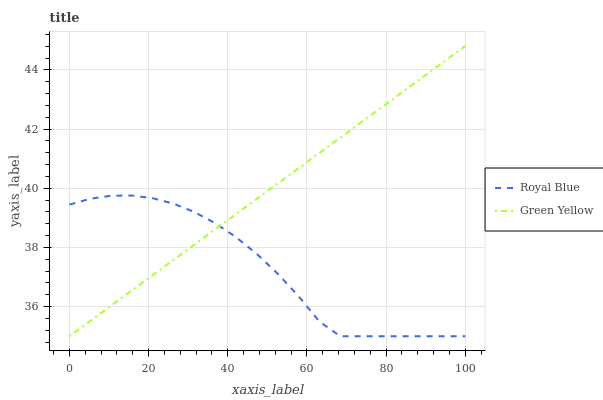Does Royal Blue have the minimum area under the curve?
Answer yes or no. Yes. Does Green Yellow have the maximum area under the curve?
Answer yes or no. Yes. Does Green Yellow have the minimum area under the curve?
Answer yes or no. No. Is Green Yellow the smoothest?
Answer yes or no. Yes. Is Royal Blue the roughest?
Answer yes or no. Yes. Is Green Yellow the roughest?
Answer yes or no. No. Does Green Yellow have the highest value?
Answer yes or no. Yes. 